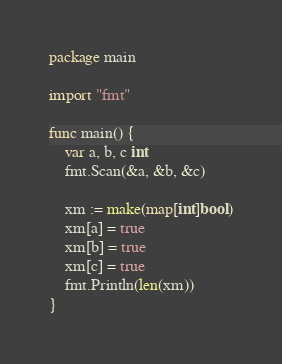Convert code to text. <code><loc_0><loc_0><loc_500><loc_500><_Go_>package main

import "fmt"

func main() {
	var a, b, c int
	fmt.Scan(&a, &b, &c)

	xm := make(map[int]bool)
	xm[a] = true
	xm[b] = true
	xm[c] = true
	fmt.Println(len(xm))
}
</code> 